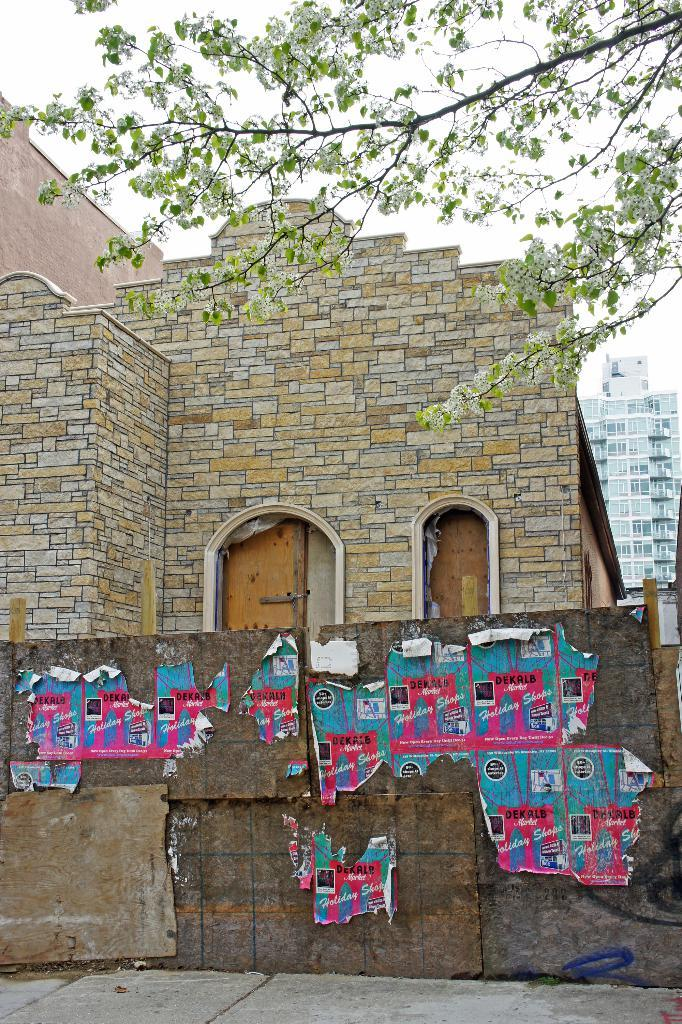What type of structures can be seen in the image? There are buildings in the image. What is on the wall in the image? There are posters on the wall in the image. What type of plant is visible in the image? There is a tree visible in the image. What is at the bottom of the image? There is a road at the bottom of the image. What is the interest rate on the mark in the image? There is no mention of interest rates or marks in the image; it features buildings, posters, a tree, and a road. 